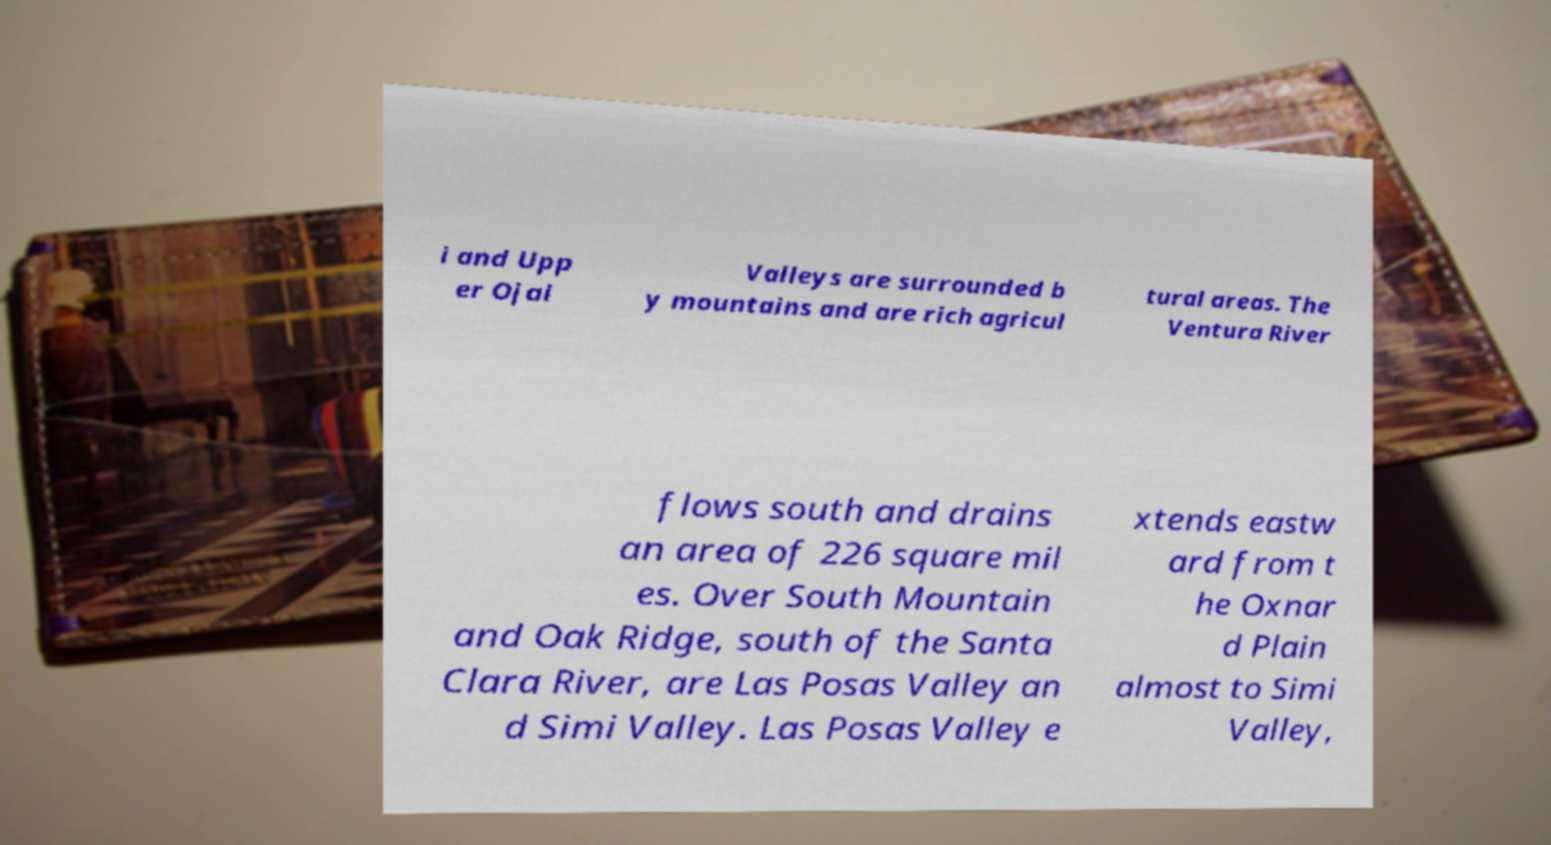What messages or text are displayed in this image? I need them in a readable, typed format. i and Upp er Ojai Valleys are surrounded b y mountains and are rich agricul tural areas. The Ventura River flows south and drains an area of 226 square mil es. Over South Mountain and Oak Ridge, south of the Santa Clara River, are Las Posas Valley an d Simi Valley. Las Posas Valley e xtends eastw ard from t he Oxnar d Plain almost to Simi Valley, 